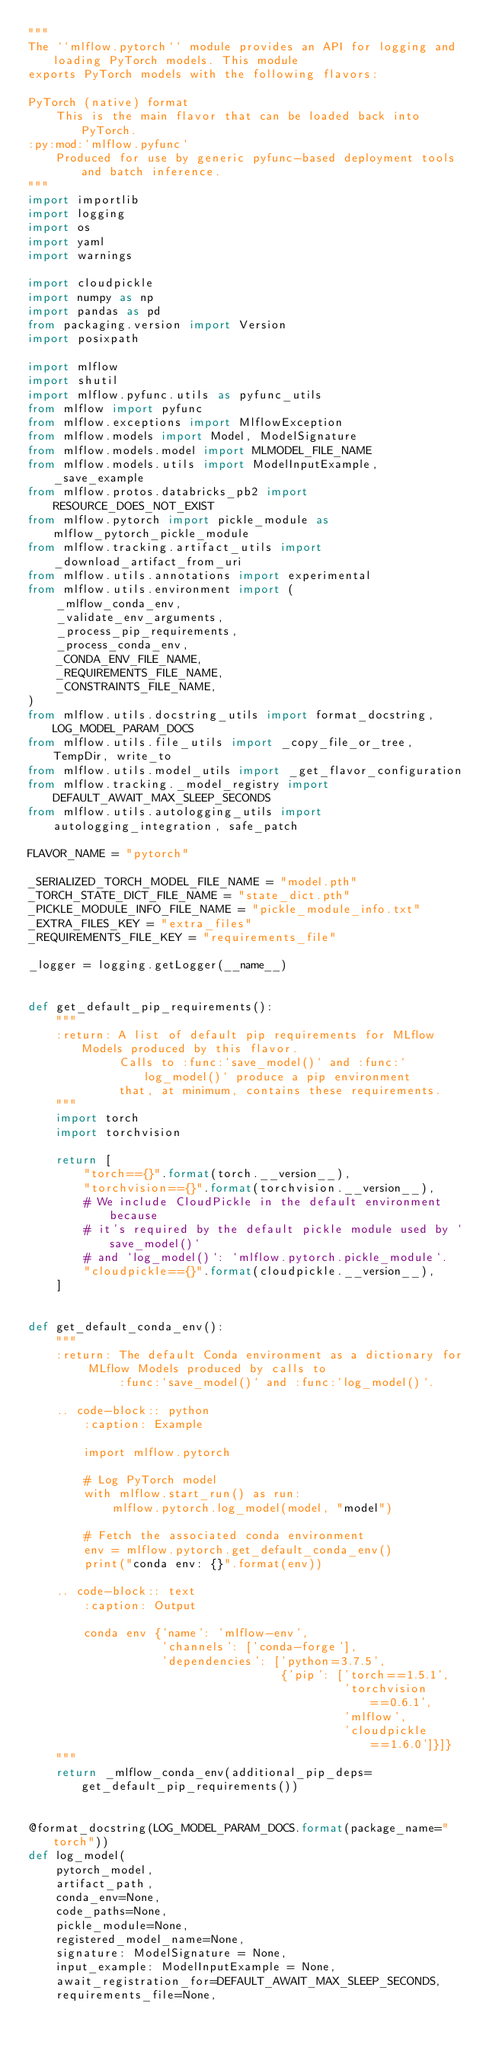<code> <loc_0><loc_0><loc_500><loc_500><_Python_>"""
The ``mlflow.pytorch`` module provides an API for logging and loading PyTorch models. This module
exports PyTorch models with the following flavors:

PyTorch (native) format
    This is the main flavor that can be loaded back into PyTorch.
:py:mod:`mlflow.pyfunc`
    Produced for use by generic pyfunc-based deployment tools and batch inference.
"""
import importlib
import logging
import os
import yaml
import warnings

import cloudpickle
import numpy as np
import pandas as pd
from packaging.version import Version
import posixpath

import mlflow
import shutil
import mlflow.pyfunc.utils as pyfunc_utils
from mlflow import pyfunc
from mlflow.exceptions import MlflowException
from mlflow.models import Model, ModelSignature
from mlflow.models.model import MLMODEL_FILE_NAME
from mlflow.models.utils import ModelInputExample, _save_example
from mlflow.protos.databricks_pb2 import RESOURCE_DOES_NOT_EXIST
from mlflow.pytorch import pickle_module as mlflow_pytorch_pickle_module
from mlflow.tracking.artifact_utils import _download_artifact_from_uri
from mlflow.utils.annotations import experimental
from mlflow.utils.environment import (
    _mlflow_conda_env,
    _validate_env_arguments,
    _process_pip_requirements,
    _process_conda_env,
    _CONDA_ENV_FILE_NAME,
    _REQUIREMENTS_FILE_NAME,
    _CONSTRAINTS_FILE_NAME,
)
from mlflow.utils.docstring_utils import format_docstring, LOG_MODEL_PARAM_DOCS
from mlflow.utils.file_utils import _copy_file_or_tree, TempDir, write_to
from mlflow.utils.model_utils import _get_flavor_configuration
from mlflow.tracking._model_registry import DEFAULT_AWAIT_MAX_SLEEP_SECONDS
from mlflow.utils.autologging_utils import autologging_integration, safe_patch

FLAVOR_NAME = "pytorch"

_SERIALIZED_TORCH_MODEL_FILE_NAME = "model.pth"
_TORCH_STATE_DICT_FILE_NAME = "state_dict.pth"
_PICKLE_MODULE_INFO_FILE_NAME = "pickle_module_info.txt"
_EXTRA_FILES_KEY = "extra_files"
_REQUIREMENTS_FILE_KEY = "requirements_file"

_logger = logging.getLogger(__name__)


def get_default_pip_requirements():
    """
    :return: A list of default pip requirements for MLflow Models produced by this flavor.
             Calls to :func:`save_model()` and :func:`log_model()` produce a pip environment
             that, at minimum, contains these requirements.
    """
    import torch
    import torchvision

    return [
        "torch=={}".format(torch.__version__),
        "torchvision=={}".format(torchvision.__version__),
        # We include CloudPickle in the default environment because
        # it's required by the default pickle module used by `save_model()`
        # and `log_model()`: `mlflow.pytorch.pickle_module`.
        "cloudpickle=={}".format(cloudpickle.__version__),
    ]


def get_default_conda_env():
    """
    :return: The default Conda environment as a dictionary for MLflow Models produced by calls to
             :func:`save_model()` and :func:`log_model()`.

    .. code-block:: python
        :caption: Example

        import mlflow.pytorch

        # Log PyTorch model
        with mlflow.start_run() as run:
            mlflow.pytorch.log_model(model, "model")

        # Fetch the associated conda environment
        env = mlflow.pytorch.get_default_conda_env()
        print("conda env: {}".format(env))

    .. code-block:: text
        :caption: Output

        conda env {'name': 'mlflow-env',
                   'channels': ['conda-forge'],
                   'dependencies': ['python=3.7.5',
                                    {'pip': ['torch==1.5.1',
                                             'torchvision==0.6.1',
                                             'mlflow',
                                             'cloudpickle==1.6.0']}]}
    """
    return _mlflow_conda_env(additional_pip_deps=get_default_pip_requirements())


@format_docstring(LOG_MODEL_PARAM_DOCS.format(package_name="torch"))
def log_model(
    pytorch_model,
    artifact_path,
    conda_env=None,
    code_paths=None,
    pickle_module=None,
    registered_model_name=None,
    signature: ModelSignature = None,
    input_example: ModelInputExample = None,
    await_registration_for=DEFAULT_AWAIT_MAX_SLEEP_SECONDS,
    requirements_file=None,</code> 